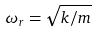Convert formula to latex. <formula><loc_0><loc_0><loc_500><loc_500>\omega _ { r } = \sqrt { k / m }</formula> 